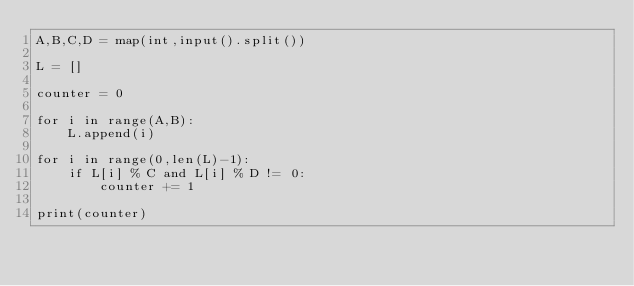Convert code to text. <code><loc_0><loc_0><loc_500><loc_500><_Python_>A,B,C,D = map(int,input().split())

L = []

counter = 0

for i in range(A,B):
	L.append(i)
	
for i in range(0,len(L)-1):
	if L[i] % C and L[i] % D != 0:
		counter += 1
		
print(counter)</code> 